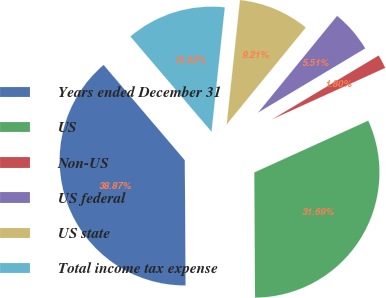Convert chart to OTSL. <chart><loc_0><loc_0><loc_500><loc_500><pie_chart><fcel>Years ended December 31<fcel>US<fcel>Non-US<fcel>US federal<fcel>US state<fcel>Total income tax expense<nl><fcel>38.87%<fcel>31.69%<fcel>1.8%<fcel>5.51%<fcel>9.21%<fcel>12.92%<nl></chart> 